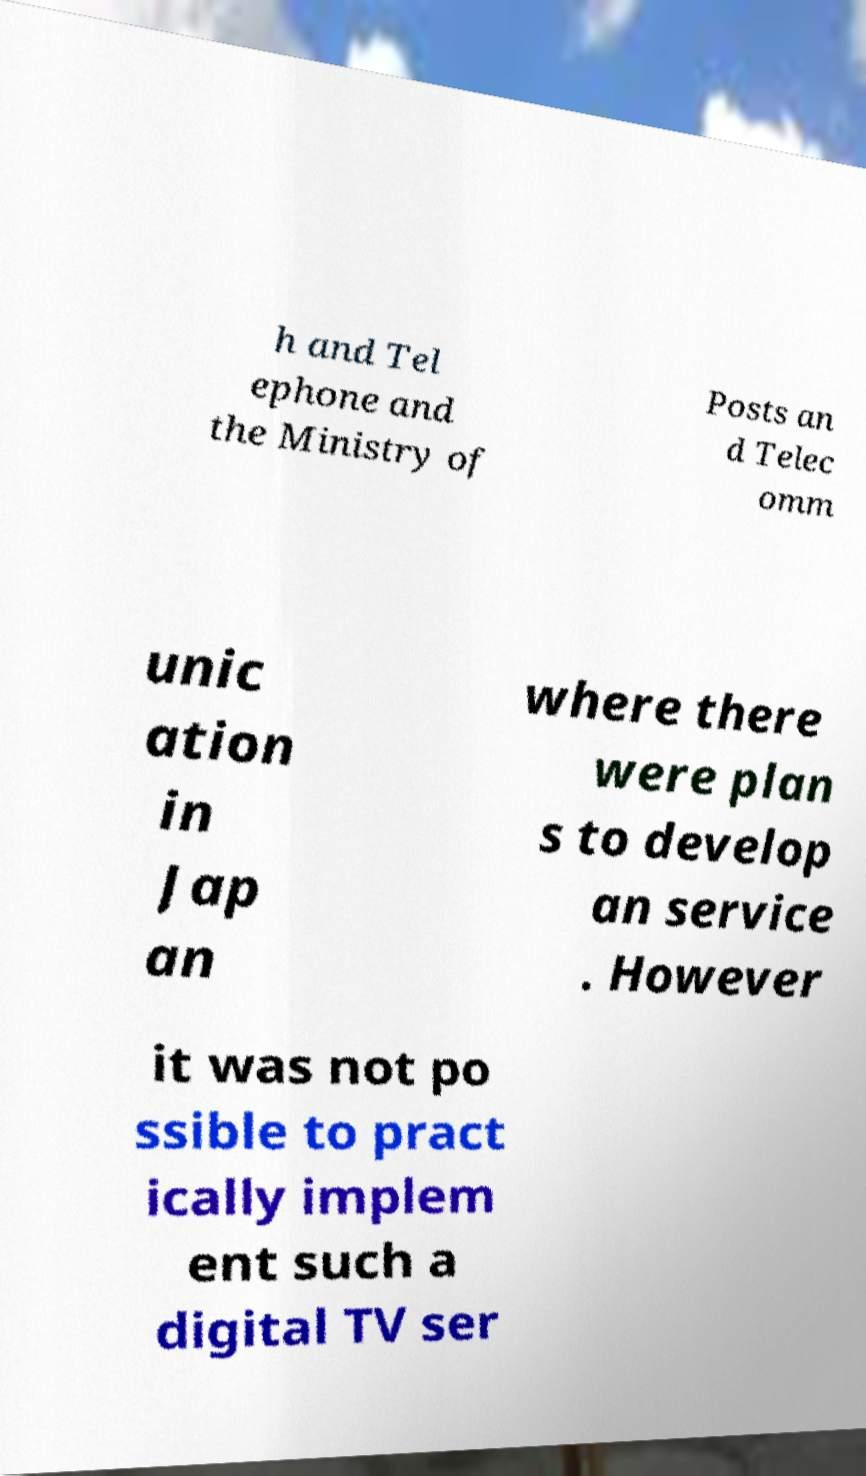Could you extract and type out the text from this image? h and Tel ephone and the Ministry of Posts an d Telec omm unic ation in Jap an where there were plan s to develop an service . However it was not po ssible to pract ically implem ent such a digital TV ser 